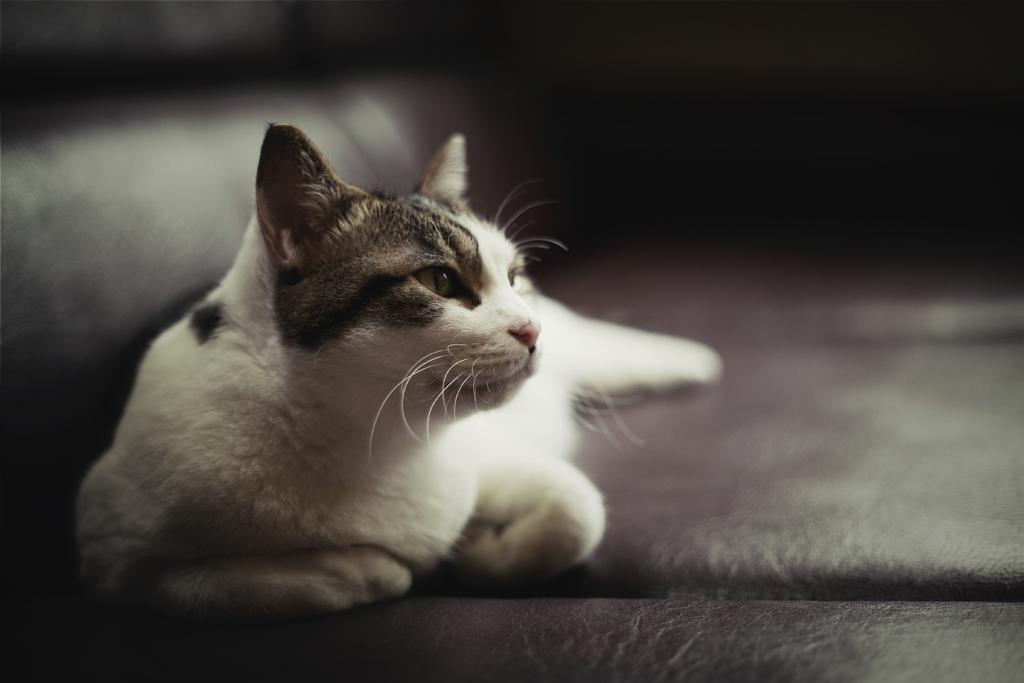What animal is present in the image? There is a cat in the image. Where is the cat located in the image? The cat is sitting on the floor. What colors can be seen on the cat? The cat has a white and brown color. Can you describe the background of the image? The background of the image is blurred. What type of tub is the fireman using to put out the spiders in the image? There is no fireman, tub, or spiders present in the image; it features a cat sitting on the floor. 